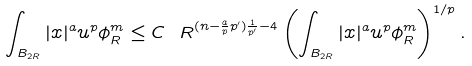Convert formula to latex. <formula><loc_0><loc_0><loc_500><loc_500>\int _ { B _ { 2 R } } | x | ^ { a } u ^ { p } \phi ^ { m } _ { R } \leq C \ R ^ { ( n - \frac { a } { p } p ^ { \prime } ) \frac { 1 } { p ^ { \prime } } - 4 } \left ( \int _ { B _ { 2 R } } | x | ^ { a } u ^ { p } \phi ^ { m } _ { R } \right ) ^ { 1 / p } .</formula> 